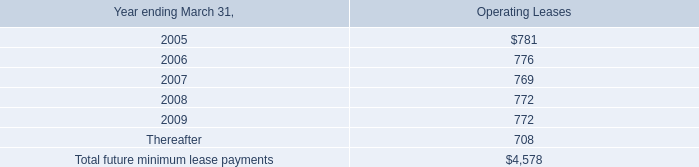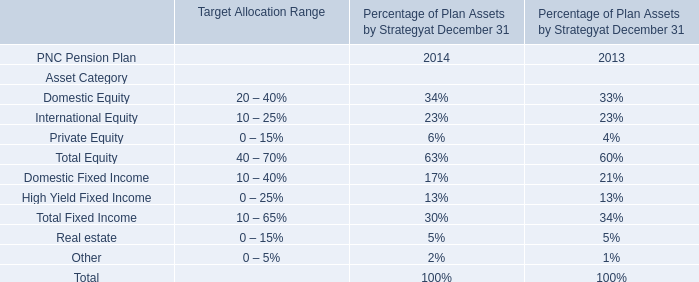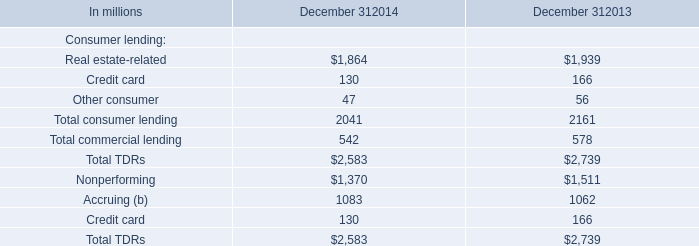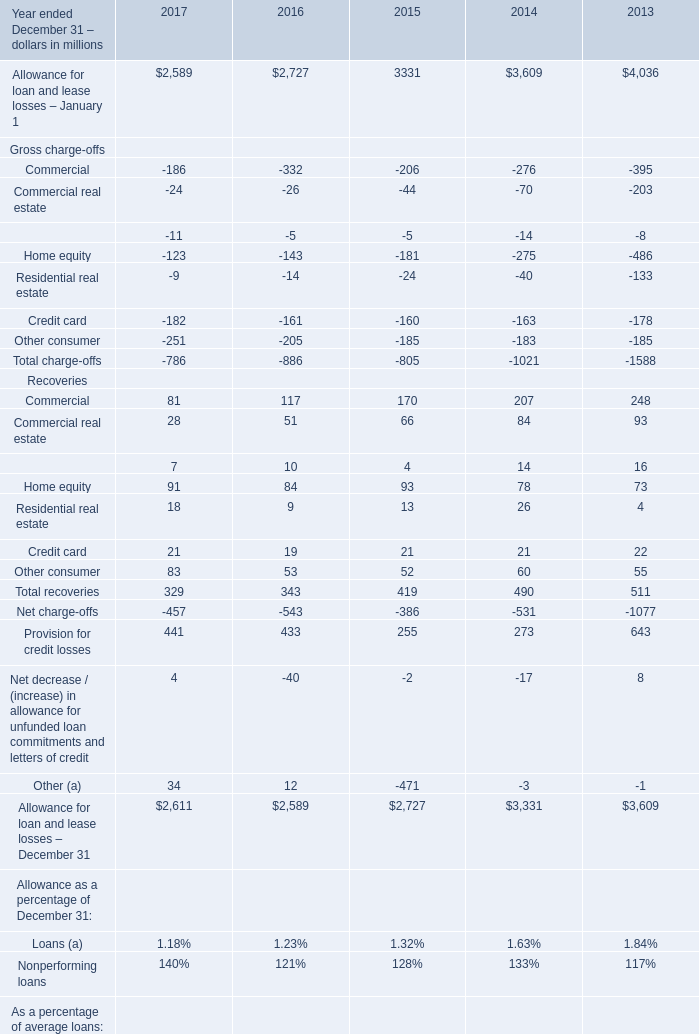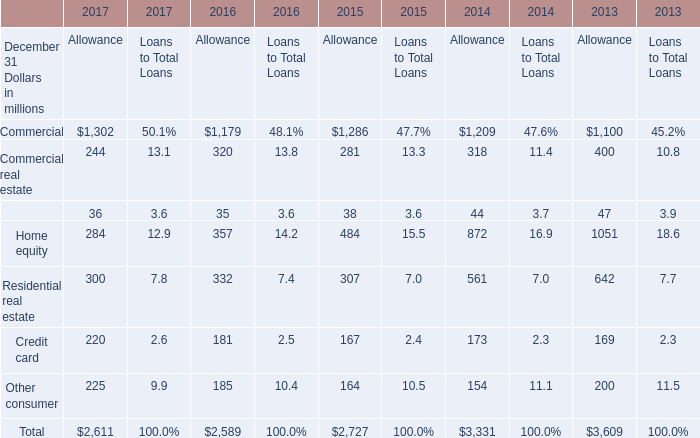How much of Allowance is there in total in 2017 without Commercial and Commercial real estate? (in million) 
Computations: ((((36 + 284) + 300) + 220) + 225)
Answer: 1065.0. 